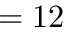Convert formula to latex. <formula><loc_0><loc_0><loc_500><loc_500>= 1 2</formula> 